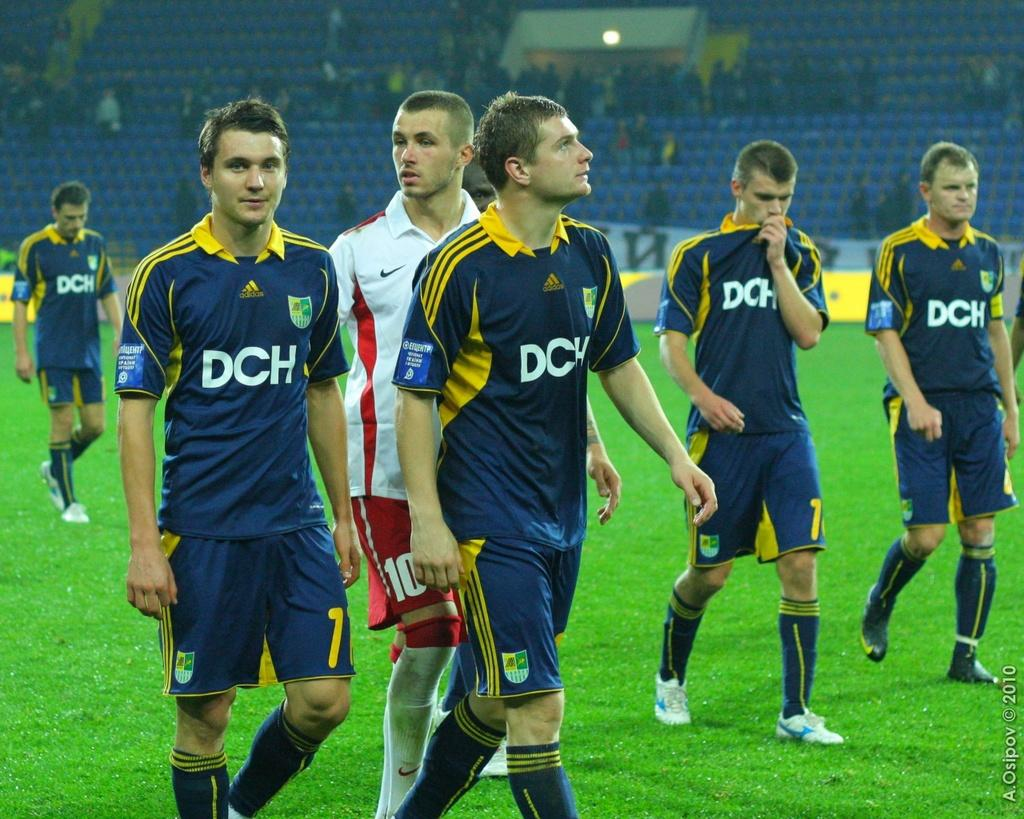<image>
Create a compact narrative representing the image presented. The DCH soccer team wears blue and yellow uniforms on the field. 